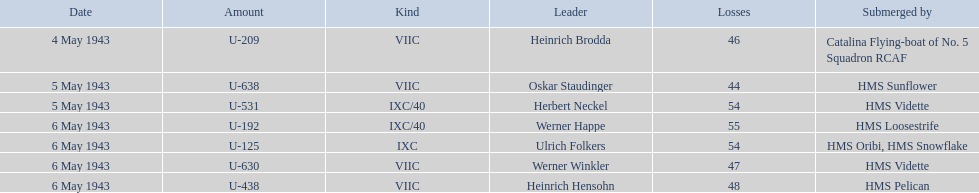Who are all of the captains? Heinrich Brodda, Oskar Staudinger, Herbert Neckel, Werner Happe, Ulrich Folkers, Werner Winkler, Heinrich Hensohn. What sunk each of the captains? Catalina Flying-boat of No. 5 Squadron RCAF, HMS Sunflower, HMS Vidette, HMS Loosestrife, HMS Oribi, HMS Snowflake, HMS Vidette, HMS Pelican. Which was sunk by the hms pelican? Heinrich Hensohn. 